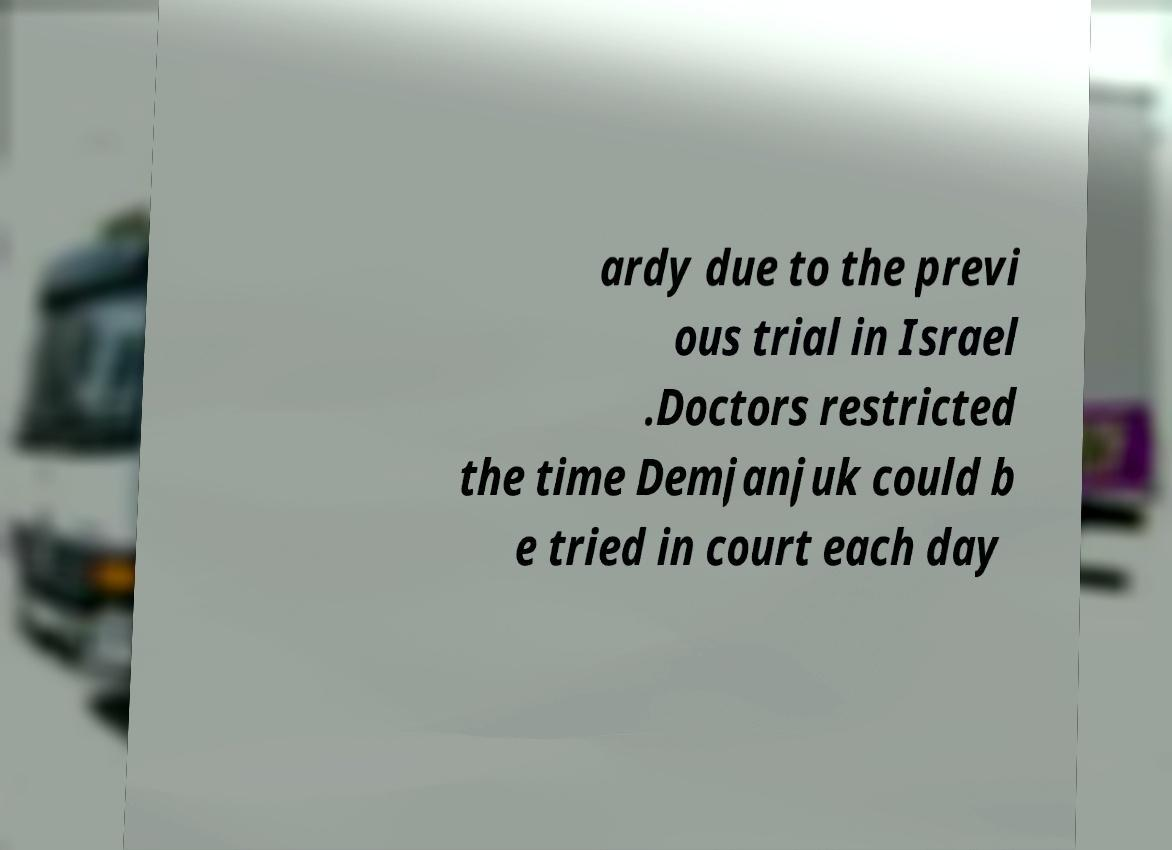What messages or text are displayed in this image? I need them in a readable, typed format. ardy due to the previ ous trial in Israel .Doctors restricted the time Demjanjuk could b e tried in court each day 